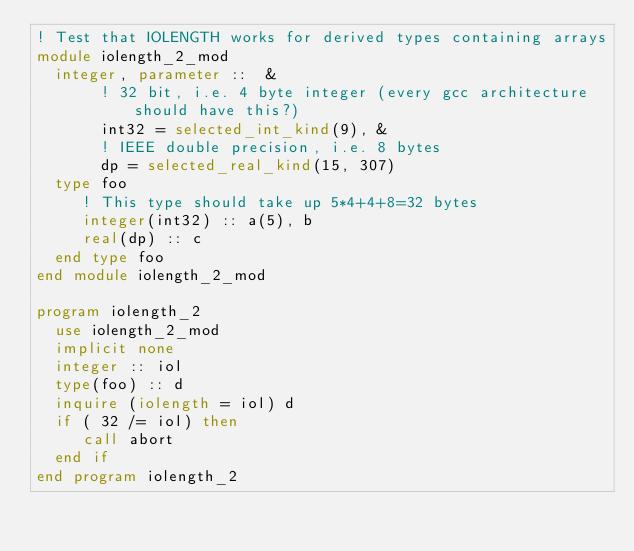Convert code to text. <code><loc_0><loc_0><loc_500><loc_500><_FORTRAN_>! Test that IOLENGTH works for derived types containing arrays
module iolength_2_mod
  integer, parameter ::  &
       ! 32 bit, i.e. 4 byte integer (every gcc architecture should have this?)
       int32 = selected_int_kind(9), &
       ! IEEE double precision, i.e. 8 bytes
       dp = selected_real_kind(15, 307)
  type foo
     ! This type should take up 5*4+4+8=32 bytes
     integer(int32) :: a(5), b
     real(dp) :: c
  end type foo
end module iolength_2_mod

program iolength_2
  use iolength_2_mod
  implicit none
  integer :: iol
  type(foo) :: d
  inquire (iolength = iol) d
  if ( 32 /= iol) then
     call abort
  end if
end program iolength_2
</code> 